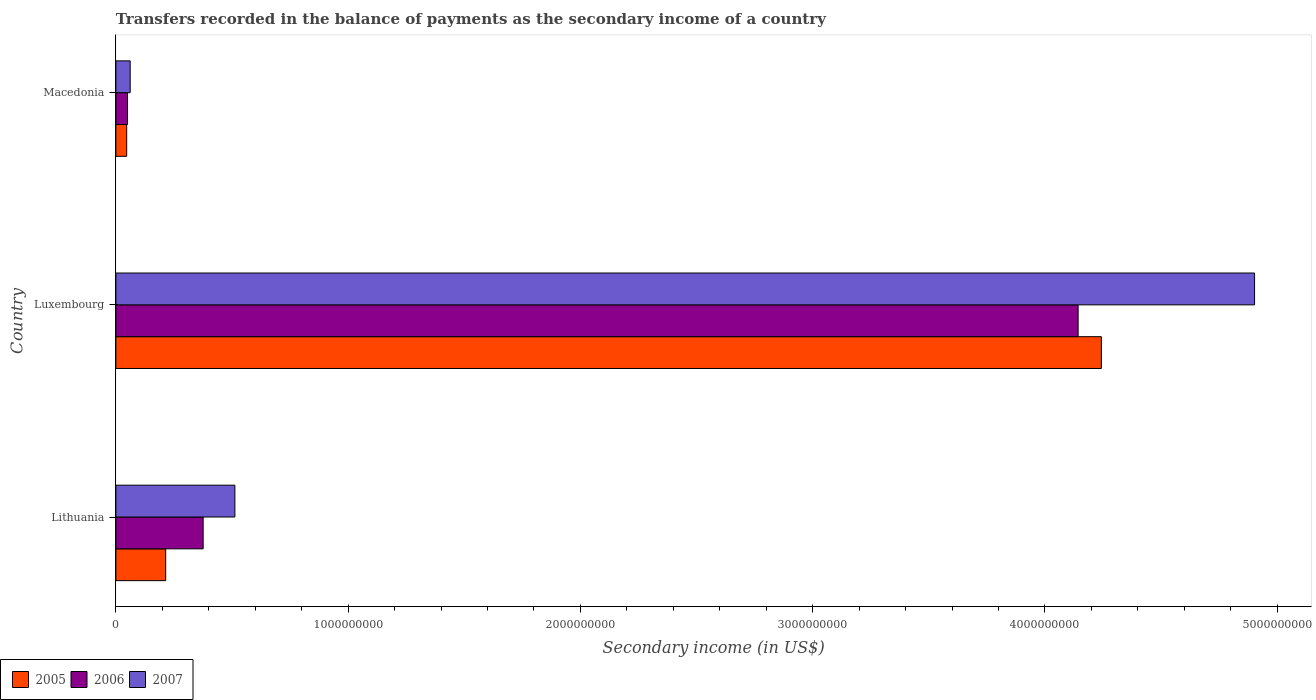How many groups of bars are there?
Give a very brief answer. 3. Are the number of bars per tick equal to the number of legend labels?
Give a very brief answer. Yes. Are the number of bars on each tick of the Y-axis equal?
Your answer should be compact. Yes. How many bars are there on the 3rd tick from the top?
Your response must be concise. 3. What is the label of the 2nd group of bars from the top?
Offer a very short reply. Luxembourg. In how many cases, is the number of bars for a given country not equal to the number of legend labels?
Provide a succinct answer. 0. What is the secondary income of in 2005 in Luxembourg?
Your response must be concise. 4.24e+09. Across all countries, what is the maximum secondary income of in 2007?
Keep it short and to the point. 4.90e+09. Across all countries, what is the minimum secondary income of in 2006?
Provide a short and direct response. 5.01e+07. In which country was the secondary income of in 2007 maximum?
Your response must be concise. Luxembourg. In which country was the secondary income of in 2005 minimum?
Provide a short and direct response. Macedonia. What is the total secondary income of in 2007 in the graph?
Keep it short and to the point. 5.48e+09. What is the difference between the secondary income of in 2007 in Lithuania and that in Macedonia?
Make the answer very short. 4.51e+08. What is the difference between the secondary income of in 2007 in Macedonia and the secondary income of in 2005 in Lithuania?
Provide a short and direct response. -1.53e+08. What is the average secondary income of in 2007 per country?
Your answer should be very brief. 1.83e+09. What is the difference between the secondary income of in 2005 and secondary income of in 2007 in Luxembourg?
Offer a very short reply. -6.60e+08. What is the ratio of the secondary income of in 2007 in Lithuania to that in Macedonia?
Your response must be concise. 8.32. What is the difference between the highest and the second highest secondary income of in 2007?
Keep it short and to the point. 4.39e+09. What is the difference between the highest and the lowest secondary income of in 2005?
Provide a short and direct response. 4.20e+09. In how many countries, is the secondary income of in 2006 greater than the average secondary income of in 2006 taken over all countries?
Ensure brevity in your answer.  1. Is the sum of the secondary income of in 2007 in Lithuania and Luxembourg greater than the maximum secondary income of in 2006 across all countries?
Offer a terse response. Yes. What does the 2nd bar from the top in Lithuania represents?
Give a very brief answer. 2006. What does the 3rd bar from the bottom in Lithuania represents?
Give a very brief answer. 2007. Is it the case that in every country, the sum of the secondary income of in 2007 and secondary income of in 2006 is greater than the secondary income of in 2005?
Provide a short and direct response. Yes. What is the difference between two consecutive major ticks on the X-axis?
Your answer should be very brief. 1.00e+09. Are the values on the major ticks of X-axis written in scientific E-notation?
Your answer should be compact. No. Does the graph contain any zero values?
Offer a terse response. No. Does the graph contain grids?
Your answer should be compact. No. Where does the legend appear in the graph?
Your answer should be compact. Bottom left. What is the title of the graph?
Provide a short and direct response. Transfers recorded in the balance of payments as the secondary income of a country. Does "1976" appear as one of the legend labels in the graph?
Keep it short and to the point. No. What is the label or title of the X-axis?
Make the answer very short. Secondary income (in US$). What is the label or title of the Y-axis?
Provide a succinct answer. Country. What is the Secondary income (in US$) of 2005 in Lithuania?
Your answer should be very brief. 2.14e+08. What is the Secondary income (in US$) of 2006 in Lithuania?
Provide a succinct answer. 3.76e+08. What is the Secondary income (in US$) in 2007 in Lithuania?
Provide a short and direct response. 5.12e+08. What is the Secondary income (in US$) of 2005 in Luxembourg?
Provide a succinct answer. 4.24e+09. What is the Secondary income (in US$) of 2006 in Luxembourg?
Offer a terse response. 4.14e+09. What is the Secondary income (in US$) in 2007 in Luxembourg?
Make the answer very short. 4.90e+09. What is the Secondary income (in US$) of 2005 in Macedonia?
Offer a terse response. 4.65e+07. What is the Secondary income (in US$) of 2006 in Macedonia?
Your response must be concise. 5.01e+07. What is the Secondary income (in US$) of 2007 in Macedonia?
Keep it short and to the point. 6.16e+07. Across all countries, what is the maximum Secondary income (in US$) of 2005?
Give a very brief answer. 4.24e+09. Across all countries, what is the maximum Secondary income (in US$) of 2006?
Give a very brief answer. 4.14e+09. Across all countries, what is the maximum Secondary income (in US$) in 2007?
Keep it short and to the point. 4.90e+09. Across all countries, what is the minimum Secondary income (in US$) in 2005?
Make the answer very short. 4.65e+07. Across all countries, what is the minimum Secondary income (in US$) of 2006?
Keep it short and to the point. 5.01e+07. Across all countries, what is the minimum Secondary income (in US$) in 2007?
Offer a very short reply. 6.16e+07. What is the total Secondary income (in US$) in 2005 in the graph?
Offer a terse response. 4.50e+09. What is the total Secondary income (in US$) of 2006 in the graph?
Offer a very short reply. 4.57e+09. What is the total Secondary income (in US$) in 2007 in the graph?
Your answer should be very brief. 5.48e+09. What is the difference between the Secondary income (in US$) in 2005 in Lithuania and that in Luxembourg?
Offer a terse response. -4.03e+09. What is the difference between the Secondary income (in US$) in 2006 in Lithuania and that in Luxembourg?
Offer a very short reply. -3.77e+09. What is the difference between the Secondary income (in US$) in 2007 in Lithuania and that in Luxembourg?
Your response must be concise. -4.39e+09. What is the difference between the Secondary income (in US$) of 2005 in Lithuania and that in Macedonia?
Offer a very short reply. 1.68e+08. What is the difference between the Secondary income (in US$) of 2006 in Lithuania and that in Macedonia?
Keep it short and to the point. 3.26e+08. What is the difference between the Secondary income (in US$) of 2007 in Lithuania and that in Macedonia?
Offer a very short reply. 4.51e+08. What is the difference between the Secondary income (in US$) of 2005 in Luxembourg and that in Macedonia?
Provide a succinct answer. 4.20e+09. What is the difference between the Secondary income (in US$) of 2006 in Luxembourg and that in Macedonia?
Ensure brevity in your answer.  4.09e+09. What is the difference between the Secondary income (in US$) in 2007 in Luxembourg and that in Macedonia?
Ensure brevity in your answer.  4.84e+09. What is the difference between the Secondary income (in US$) in 2005 in Lithuania and the Secondary income (in US$) in 2006 in Luxembourg?
Offer a very short reply. -3.93e+09. What is the difference between the Secondary income (in US$) in 2005 in Lithuania and the Secondary income (in US$) in 2007 in Luxembourg?
Offer a very short reply. -4.69e+09. What is the difference between the Secondary income (in US$) of 2006 in Lithuania and the Secondary income (in US$) of 2007 in Luxembourg?
Your response must be concise. -4.53e+09. What is the difference between the Secondary income (in US$) in 2005 in Lithuania and the Secondary income (in US$) in 2006 in Macedonia?
Your answer should be very brief. 1.64e+08. What is the difference between the Secondary income (in US$) of 2005 in Lithuania and the Secondary income (in US$) of 2007 in Macedonia?
Offer a terse response. 1.53e+08. What is the difference between the Secondary income (in US$) of 2006 in Lithuania and the Secondary income (in US$) of 2007 in Macedonia?
Provide a succinct answer. 3.14e+08. What is the difference between the Secondary income (in US$) of 2005 in Luxembourg and the Secondary income (in US$) of 2006 in Macedonia?
Make the answer very short. 4.19e+09. What is the difference between the Secondary income (in US$) in 2005 in Luxembourg and the Secondary income (in US$) in 2007 in Macedonia?
Give a very brief answer. 4.18e+09. What is the difference between the Secondary income (in US$) of 2006 in Luxembourg and the Secondary income (in US$) of 2007 in Macedonia?
Your response must be concise. 4.08e+09. What is the average Secondary income (in US$) of 2005 per country?
Your answer should be compact. 1.50e+09. What is the average Secondary income (in US$) of 2006 per country?
Your answer should be compact. 1.52e+09. What is the average Secondary income (in US$) of 2007 per country?
Keep it short and to the point. 1.83e+09. What is the difference between the Secondary income (in US$) of 2005 and Secondary income (in US$) of 2006 in Lithuania?
Provide a succinct answer. -1.61e+08. What is the difference between the Secondary income (in US$) in 2005 and Secondary income (in US$) in 2007 in Lithuania?
Give a very brief answer. -2.98e+08. What is the difference between the Secondary income (in US$) in 2006 and Secondary income (in US$) in 2007 in Lithuania?
Offer a very short reply. -1.37e+08. What is the difference between the Secondary income (in US$) in 2005 and Secondary income (in US$) in 2006 in Luxembourg?
Your response must be concise. 1.00e+08. What is the difference between the Secondary income (in US$) of 2005 and Secondary income (in US$) of 2007 in Luxembourg?
Offer a very short reply. -6.60e+08. What is the difference between the Secondary income (in US$) of 2006 and Secondary income (in US$) of 2007 in Luxembourg?
Provide a short and direct response. -7.60e+08. What is the difference between the Secondary income (in US$) in 2005 and Secondary income (in US$) in 2006 in Macedonia?
Keep it short and to the point. -3.63e+06. What is the difference between the Secondary income (in US$) in 2005 and Secondary income (in US$) in 2007 in Macedonia?
Your answer should be very brief. -1.51e+07. What is the difference between the Secondary income (in US$) in 2006 and Secondary income (in US$) in 2007 in Macedonia?
Offer a very short reply. -1.14e+07. What is the ratio of the Secondary income (in US$) of 2005 in Lithuania to that in Luxembourg?
Provide a short and direct response. 0.05. What is the ratio of the Secondary income (in US$) of 2006 in Lithuania to that in Luxembourg?
Give a very brief answer. 0.09. What is the ratio of the Secondary income (in US$) in 2007 in Lithuania to that in Luxembourg?
Your response must be concise. 0.1. What is the ratio of the Secondary income (in US$) in 2005 in Lithuania to that in Macedonia?
Your answer should be compact. 4.61. What is the ratio of the Secondary income (in US$) of 2006 in Lithuania to that in Macedonia?
Your response must be concise. 7.5. What is the ratio of the Secondary income (in US$) of 2007 in Lithuania to that in Macedonia?
Give a very brief answer. 8.32. What is the ratio of the Secondary income (in US$) of 2005 in Luxembourg to that in Macedonia?
Your response must be concise. 91.26. What is the ratio of the Secondary income (in US$) in 2006 in Luxembourg to that in Macedonia?
Give a very brief answer. 82.66. What is the ratio of the Secondary income (in US$) in 2007 in Luxembourg to that in Macedonia?
Make the answer very short. 79.65. What is the difference between the highest and the second highest Secondary income (in US$) in 2005?
Your answer should be very brief. 4.03e+09. What is the difference between the highest and the second highest Secondary income (in US$) of 2006?
Offer a terse response. 3.77e+09. What is the difference between the highest and the second highest Secondary income (in US$) in 2007?
Your answer should be compact. 4.39e+09. What is the difference between the highest and the lowest Secondary income (in US$) of 2005?
Your response must be concise. 4.20e+09. What is the difference between the highest and the lowest Secondary income (in US$) in 2006?
Ensure brevity in your answer.  4.09e+09. What is the difference between the highest and the lowest Secondary income (in US$) in 2007?
Provide a short and direct response. 4.84e+09. 